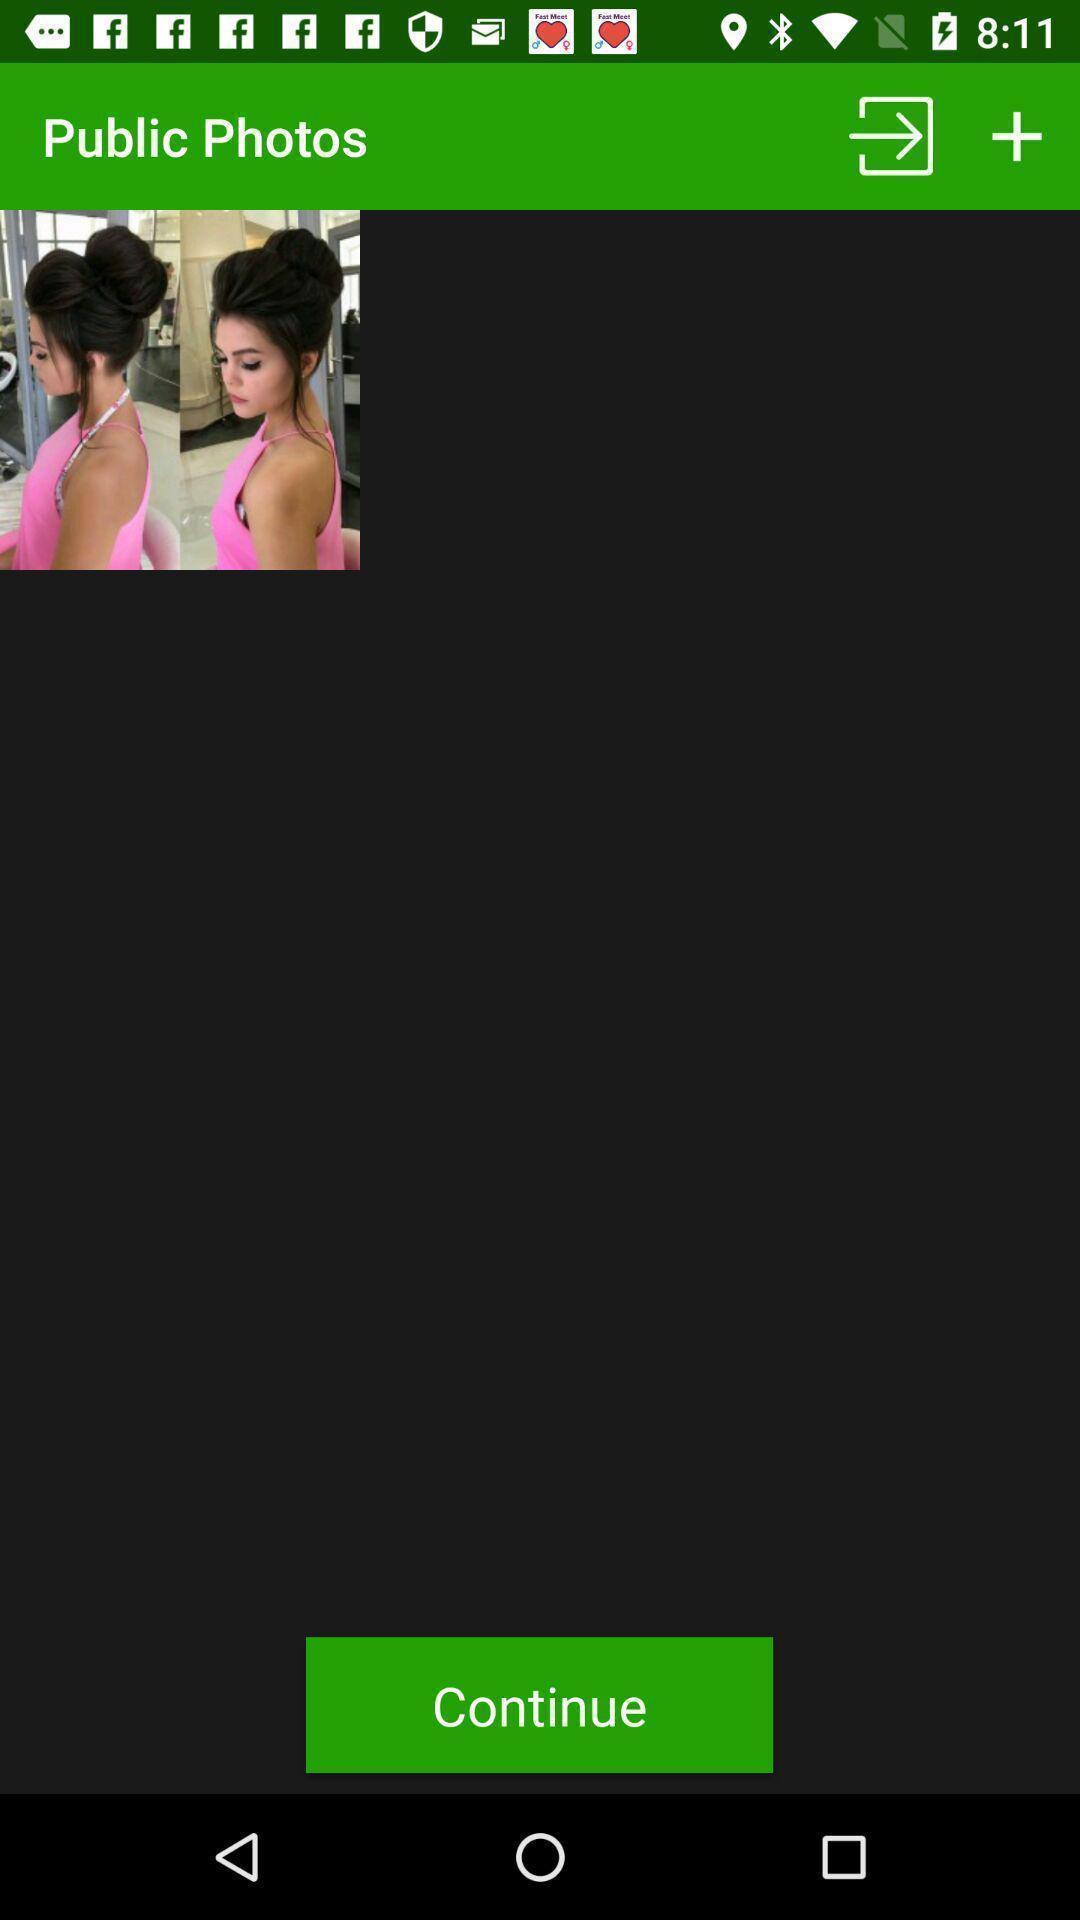Give me a summary of this screen capture. Photograph on the page and continue option. 